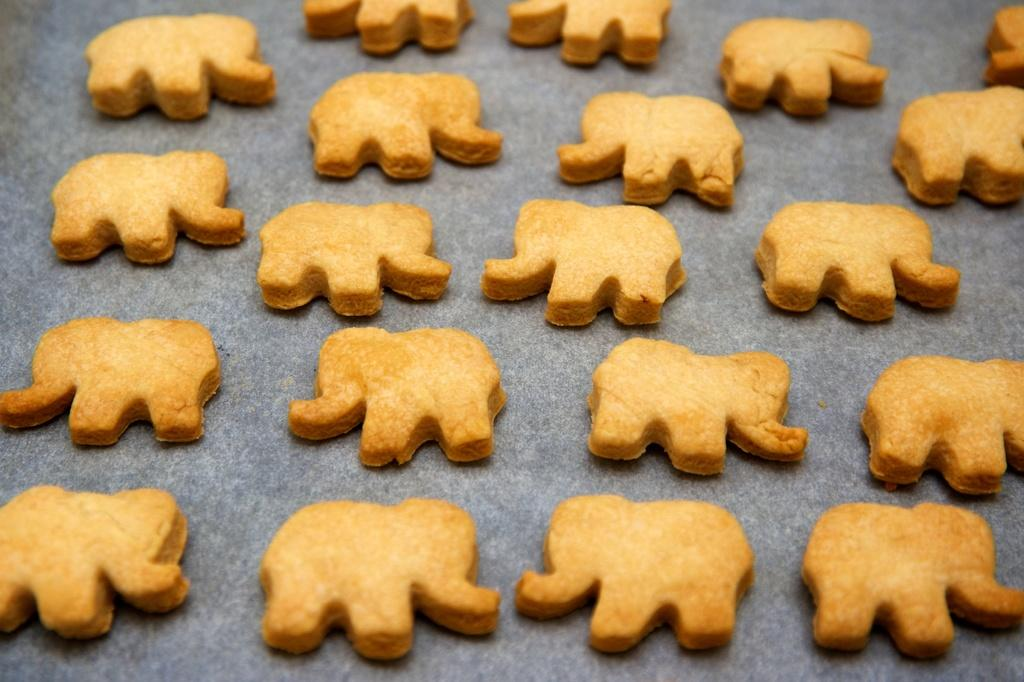What is present in the image that has a design on it? There is a cloth in the image that has an elephant design. What type of item is featured on the cloth? The cloth has elephant design cookies on it. What color are the cookies on the cloth? The cookies are in brown color. What type of wood is used to make the base of the wren's nest in the image? There is no wren or nest present in the image; it features a cloth with elephant design cookies. 